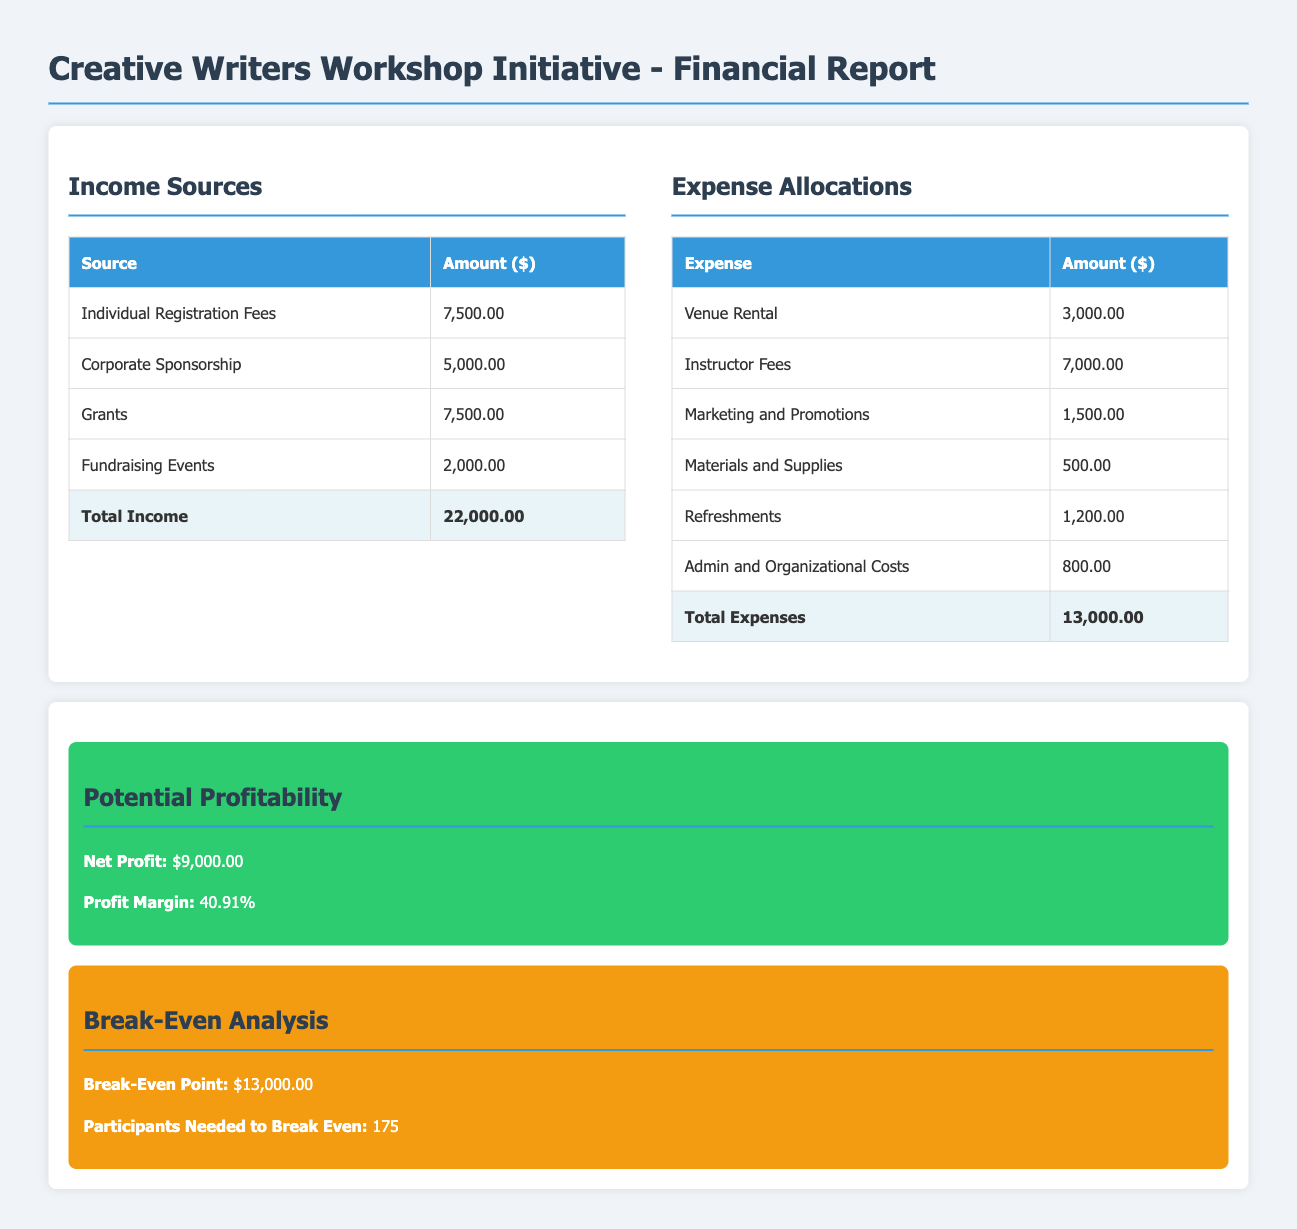What are the income sources listed? The income sources are detailed in the income section of the document, including individual registration fees, corporate sponsorship, grants, and fundraising events.
Answer: Individual Registration Fees, Corporate Sponsorship, Grants, Fundraising Events What is the total income amount? The total income is highlighted at the bottom of the income table, which is the sum of all income sources.
Answer: 22,000.00 What is the largest expense listed? The largest expense can be identified from the expenses table, which lists instructor fees as the highest amount.
Answer: 7,000.00 What are the total expenses? The total expenses are shown at the bottom of the expenses table, indicating the overall amount spent.
Answer: 13,000.00 What is the net profit? The net profit is specified in the potential profitability section of the report as the difference between total income and total expenses.
Answer: 9,000.00 What is the profit margin? The profit margin is calculated based on the net profit and total income, presented in the potential profitability section.
Answer: 40.91% What is the break-even point? The break-even point is provided in the break-even analysis section, indicating how much revenue is needed to cover expenses.
Answer: 13,000.00 How many participants are needed to break even? The number of participants needed is stated in the break-even analysis section, which determines the level of participation required to cover costs.
Answer: 175 